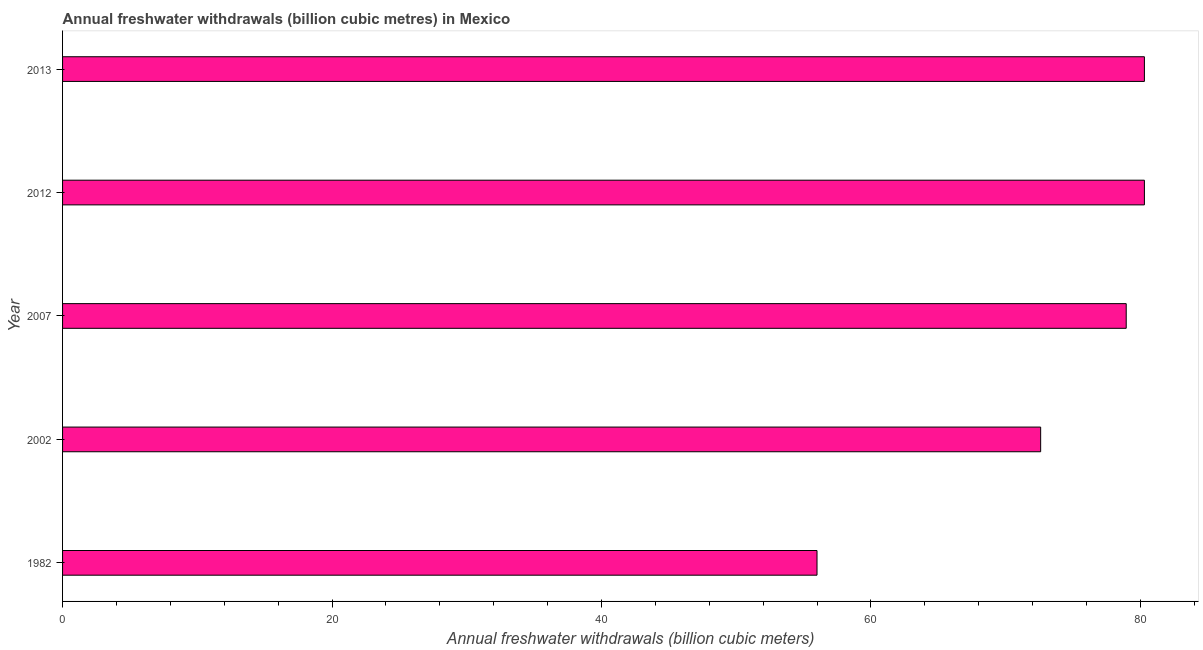Does the graph contain grids?
Ensure brevity in your answer.  No. What is the title of the graph?
Offer a terse response. Annual freshwater withdrawals (billion cubic metres) in Mexico. What is the label or title of the X-axis?
Keep it short and to the point. Annual freshwater withdrawals (billion cubic meters). What is the annual freshwater withdrawals in 2007?
Your response must be concise. 78.95. Across all years, what is the maximum annual freshwater withdrawals?
Your response must be concise. 80.3. Across all years, what is the minimum annual freshwater withdrawals?
Your answer should be compact. 56. In which year was the annual freshwater withdrawals maximum?
Provide a succinct answer. 2012. What is the sum of the annual freshwater withdrawals?
Your response must be concise. 368.15. What is the difference between the annual freshwater withdrawals in 2002 and 2013?
Your answer should be very brief. -7.7. What is the average annual freshwater withdrawals per year?
Your response must be concise. 73.63. What is the median annual freshwater withdrawals?
Provide a short and direct response. 78.95. In how many years, is the annual freshwater withdrawals greater than 4 billion cubic meters?
Provide a short and direct response. 5. Is the annual freshwater withdrawals in 2002 less than that in 2007?
Make the answer very short. Yes. What is the difference between the highest and the lowest annual freshwater withdrawals?
Give a very brief answer. 24.3. In how many years, is the annual freshwater withdrawals greater than the average annual freshwater withdrawals taken over all years?
Provide a succinct answer. 3. Are the values on the major ticks of X-axis written in scientific E-notation?
Offer a very short reply. No. What is the Annual freshwater withdrawals (billion cubic meters) in 2002?
Your answer should be compact. 72.6. What is the Annual freshwater withdrawals (billion cubic meters) in 2007?
Ensure brevity in your answer.  78.95. What is the Annual freshwater withdrawals (billion cubic meters) of 2012?
Your answer should be compact. 80.3. What is the Annual freshwater withdrawals (billion cubic meters) of 2013?
Make the answer very short. 80.3. What is the difference between the Annual freshwater withdrawals (billion cubic meters) in 1982 and 2002?
Make the answer very short. -16.6. What is the difference between the Annual freshwater withdrawals (billion cubic meters) in 1982 and 2007?
Make the answer very short. -22.95. What is the difference between the Annual freshwater withdrawals (billion cubic meters) in 1982 and 2012?
Offer a very short reply. -24.3. What is the difference between the Annual freshwater withdrawals (billion cubic meters) in 1982 and 2013?
Provide a short and direct response. -24.3. What is the difference between the Annual freshwater withdrawals (billion cubic meters) in 2002 and 2007?
Ensure brevity in your answer.  -6.35. What is the difference between the Annual freshwater withdrawals (billion cubic meters) in 2002 and 2012?
Provide a succinct answer. -7.7. What is the difference between the Annual freshwater withdrawals (billion cubic meters) in 2002 and 2013?
Your answer should be compact. -7.7. What is the difference between the Annual freshwater withdrawals (billion cubic meters) in 2007 and 2012?
Your response must be concise. -1.35. What is the difference between the Annual freshwater withdrawals (billion cubic meters) in 2007 and 2013?
Offer a very short reply. -1.35. What is the difference between the Annual freshwater withdrawals (billion cubic meters) in 2012 and 2013?
Offer a terse response. 0. What is the ratio of the Annual freshwater withdrawals (billion cubic meters) in 1982 to that in 2002?
Give a very brief answer. 0.77. What is the ratio of the Annual freshwater withdrawals (billion cubic meters) in 1982 to that in 2007?
Keep it short and to the point. 0.71. What is the ratio of the Annual freshwater withdrawals (billion cubic meters) in 1982 to that in 2012?
Provide a short and direct response. 0.7. What is the ratio of the Annual freshwater withdrawals (billion cubic meters) in 1982 to that in 2013?
Offer a very short reply. 0.7. What is the ratio of the Annual freshwater withdrawals (billion cubic meters) in 2002 to that in 2012?
Your answer should be compact. 0.9. What is the ratio of the Annual freshwater withdrawals (billion cubic meters) in 2002 to that in 2013?
Your answer should be very brief. 0.9. What is the ratio of the Annual freshwater withdrawals (billion cubic meters) in 2007 to that in 2013?
Offer a very short reply. 0.98. 